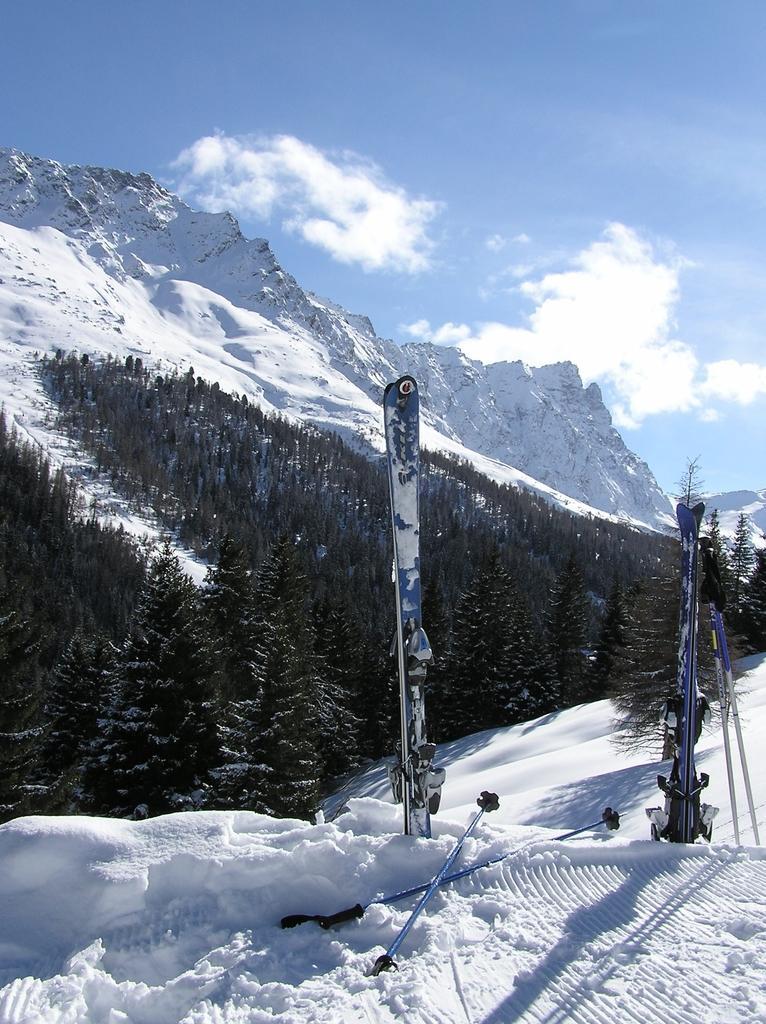In one or two sentences, can you explain what this image depicts? In this image I can see the ski-boards and the sticks on the snow. In the background I can see the trees, mountains, clouds and the sky. 